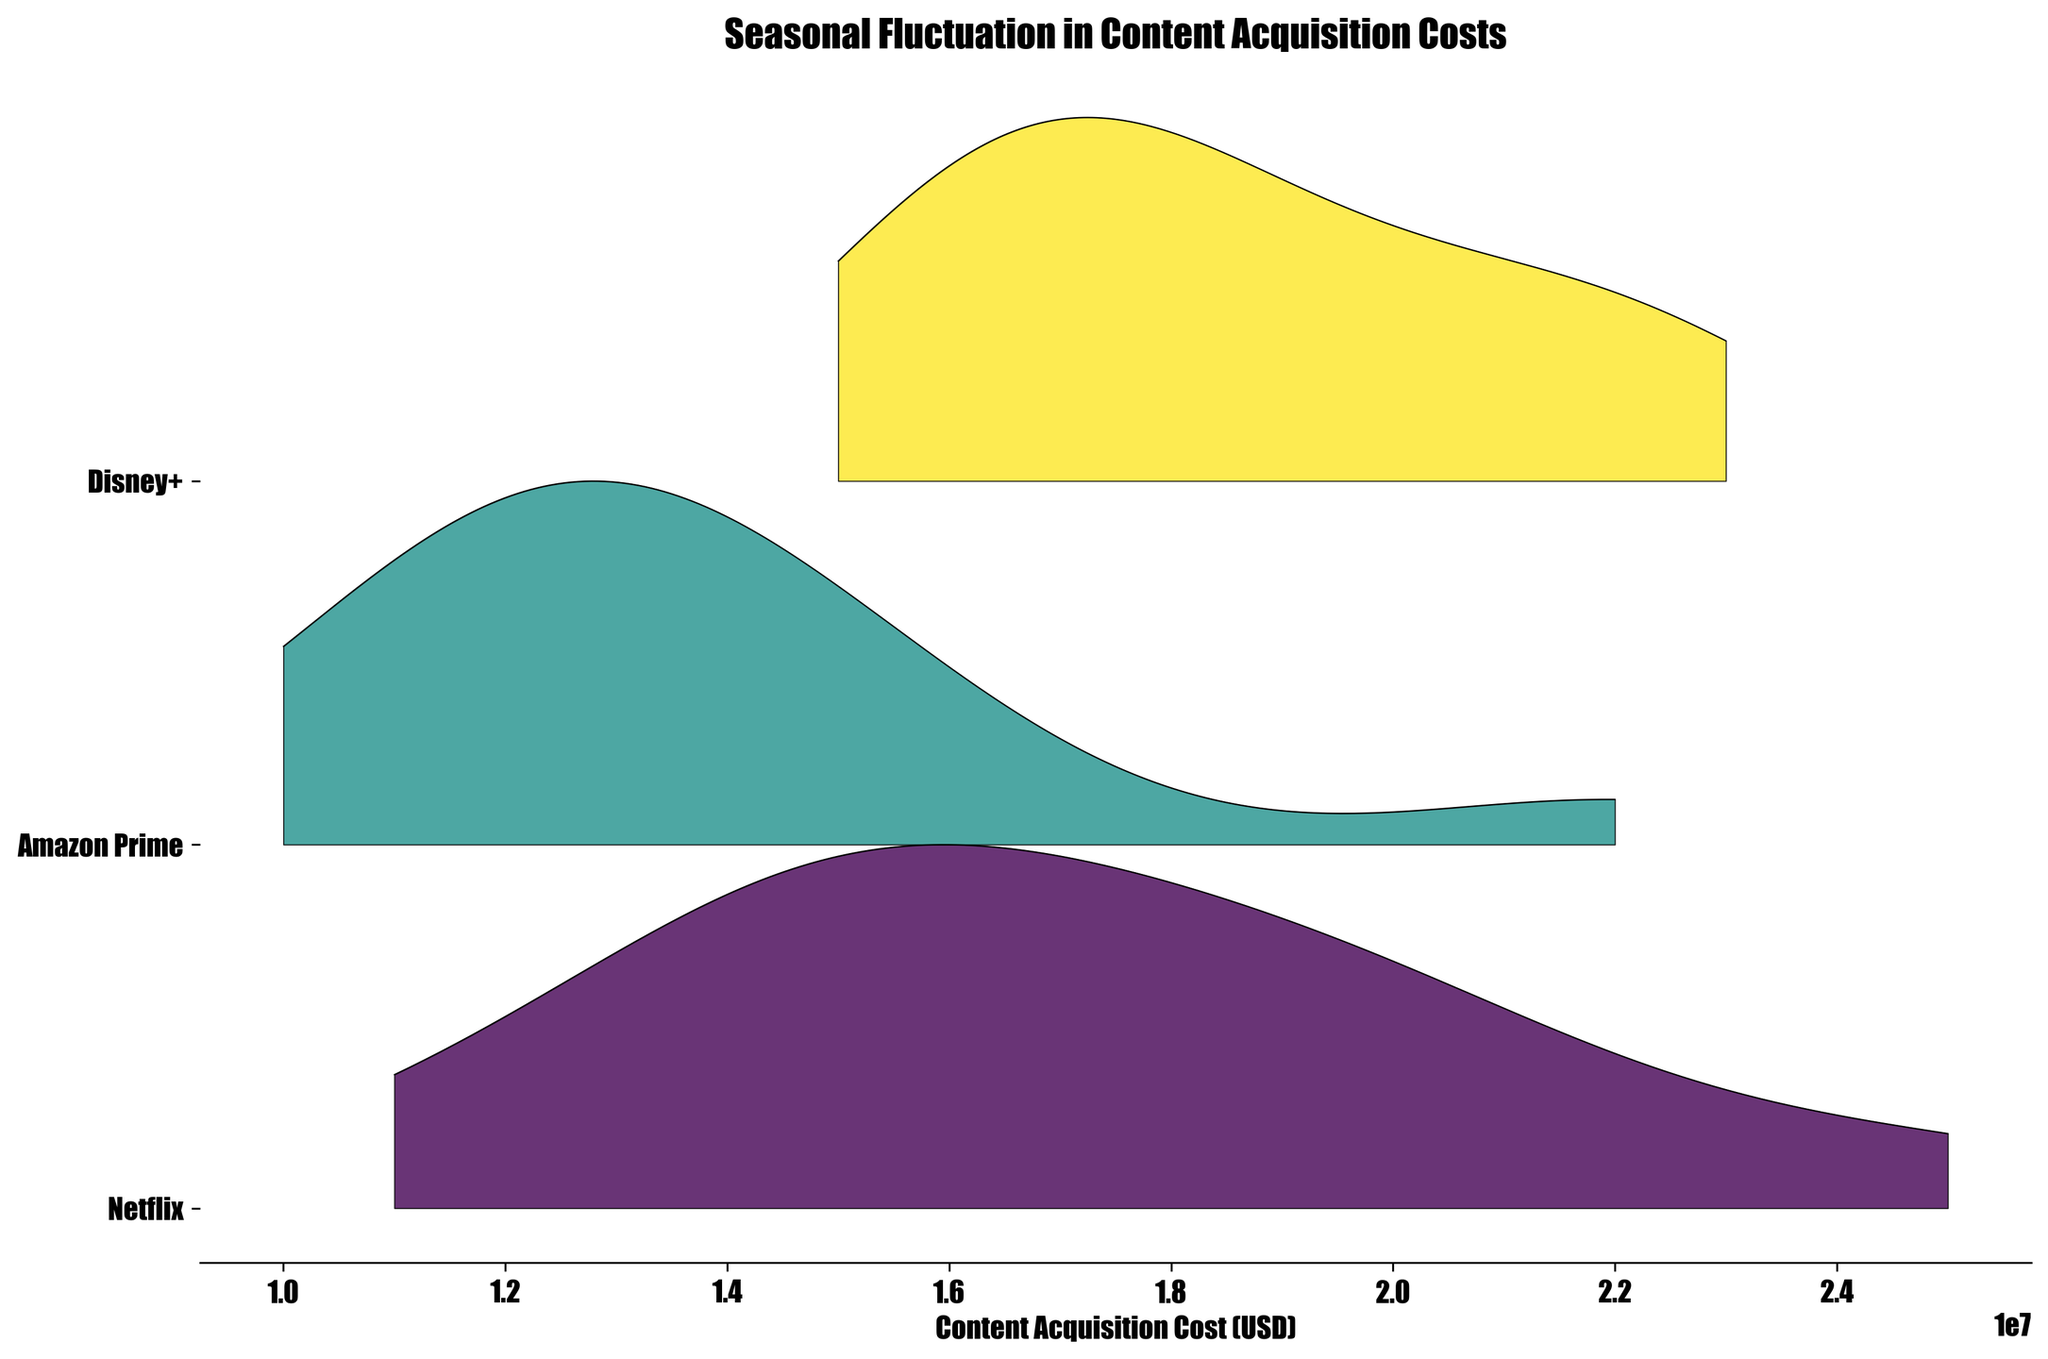What is the title of the plot? The title of the plot is the text located at the top of the figure. It is usually in bigger and bold font. In this case, the title is "Seasonal Fluctuation in Content Acquisition Costs".
Answer: Seasonal Fluctuation in Content Acquisition Costs What is the range of content acquisition costs depicted on the x-axis? The range can be determined by observing the minimum and maximum values on the x-axis, which represent the content acquisition costs. From the data provided, the costs range between 10,000,000 and 25,000,000 USD.
Answer: 10,000,000 to 25,000,000 USD How do the content acquisition costs for Netflix compare to Disney+? By examining the ridgelines for Netflix and Disney+ along the y-axis, one can see the spread and peaks of the distributions. Disney+ generally has higher peaks, indicating they tend to spend more.
Answer: Disney+ tends to have higher content acquisition costs than Netflix Which platform has the highest recorded content acquisition cost and in which month? Look for the peak value across all platforms and months. The highest recorded cost from the data is for Netflix's "Squid Game S2" in May, at 25,000,000 USD.
Answer: Netflix's "Squid Game S2" in May What is the monthly trend in content acquisition costs for Amazon Prime? To determine this, observe the positioning and spread of the ridgeline for Amazon Prime across the months. Although individual monthly details are complex, the distribution seems relatively more spread out with peaks in February and April, indicating higher spending in these months.
Answer: Higher spending in February and April For which platform is the variation in content acquisition costs the widest? The width of the distribution on the horizontal axis indicates the spread of costs. Netflix appears to have a broader spread compared to others.
Answer: Netflix Which month seems to have the most dollars spent on content acquisition across all platforms? Sum the peaks for each month across all platforms. Observing the combined height of ridgelines, May seems to have the highest.
Answer: May Does any platform show a consistent peak in content acquisition costs month over month? Check if any platform's ridgeline shows a recurring peak at a specific cost level consistently for multiple months. Disney+ ridgeline peaks consistently fall around the higher end of the cost range.
Answer: Disney+ Which platform has the most diverse distribution in its content acquisition costs? The platform with the broadest and most scattered ridgeline indicates diverse spending. Netflix appears to have a more varied distribution compared to Amazon Prime and Disney+.
Answer: Netflix What is the average content acquisition cost for Disney+ in the months provided? To calculate average, sum up the Disney+ cost entries and divide by the number of months. Sum = (18000000 + 16000000 + 19000000 + 21000000 + 18000000 + 17000000 + 20000000 + 15000000 + 16000000 + 17000000 + 23000000 + 22000000) = 221000000. There are 12 data points, so average = 221000000 / 12 = 18416666.67 USD.
Answer: 18416666.67 USD 